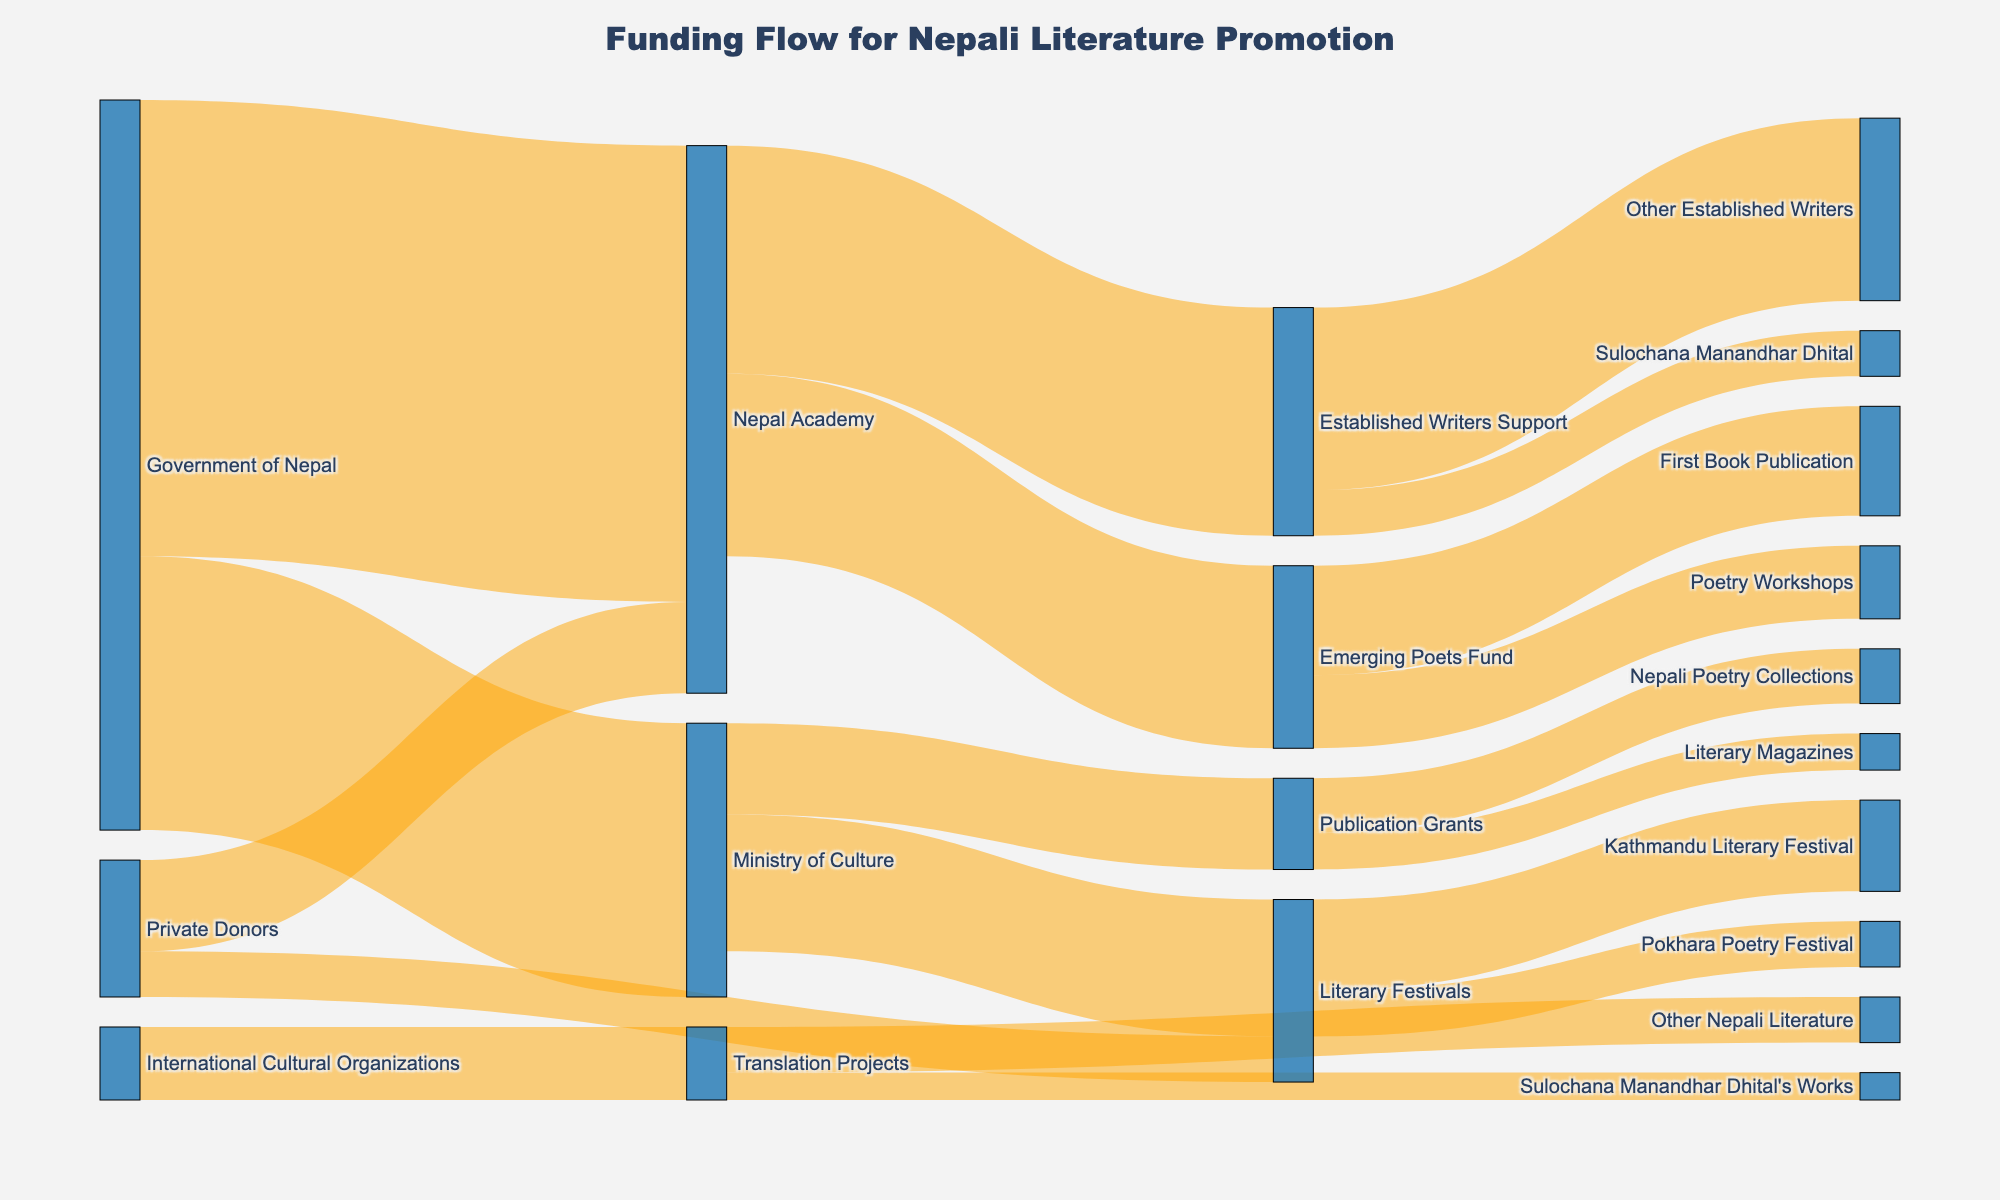How much funding does the Emerging Poets Fund receive from the Nepal Academy? The Emerging Poets Fund receives direct funding from the Nepal Academy, which can be found by following the link from the Nepal Academy node to the Emerging Poets Fund node. The value is denoted as 200,000.
Answer: 200,000 Which entity provides the highest amount of funding to the Nepal Academy? There are two sources of funding for the Nepal Academy: the Government of Nepal and Private Donors. Comparing their funding amounts, the Government of Nepal contributes 500,000, while Private Donors contribute 100,000.
Answer: Government of Nepal What is the total funding allocated for Sulochana Manandhar Dhital's support? Sulochana Manandhar Dhital receives funding through two channels: Established Writers Support (50,000) and Translation Projects (30,000). Summing these amounts gives 50,000 + 30,000.
Answer: 80,000 How much funding is directed towards Translation Projects from International Cultural Organizations? Looking at the flow from International Cultural Organizations to Translation Projects, the amount is indicated as 80,000.
Answer: 80,000 Which funding source allocates money to both Literary Festivals and the Nepal Academy? To identify the common source, we trace the flow from each funding source. Private Donors allocate funding to both Literary Festivals (50,000) and the Nepal Academy (100,000).
Answer: Private Donors What is the combined total amount of funding received by Sulochana Manandhar Dhital and other established writers? The funding received by Sulochana Manandhar Dhital is 50,000, and for Other Established Writers, it is 200,000. Adding these amounts gives 50,000 + 200,000.
Answer: 250,000 How much more funding does the First Book Publication receive compared to Poetry Workshops? The amount allocated to the First Book Publication is 120,000, and for Poetry Workshops, it is 80,000. Subtracting these amounts gives 120,000 - 80,000.
Answer: 40,000 Which has a higher allocation, Kathmandu Literary Festival or Translation Projects? Allocations for Kathmandu Literary Festival and Translation Projects are 100,000 and 80,000, respectively. Comparing these amounts shows that Kathmandu Literary Festival has a higher allocation.
Answer: Kathmandu Literary Festival From which two entities does the Ministry of Culture receive its funding? The Ministry of Culture receives funding from the Government of Nepal (300,000). There are no other entities providing direct funding to the Ministry of Culture.
Answer: Government of Nepal 